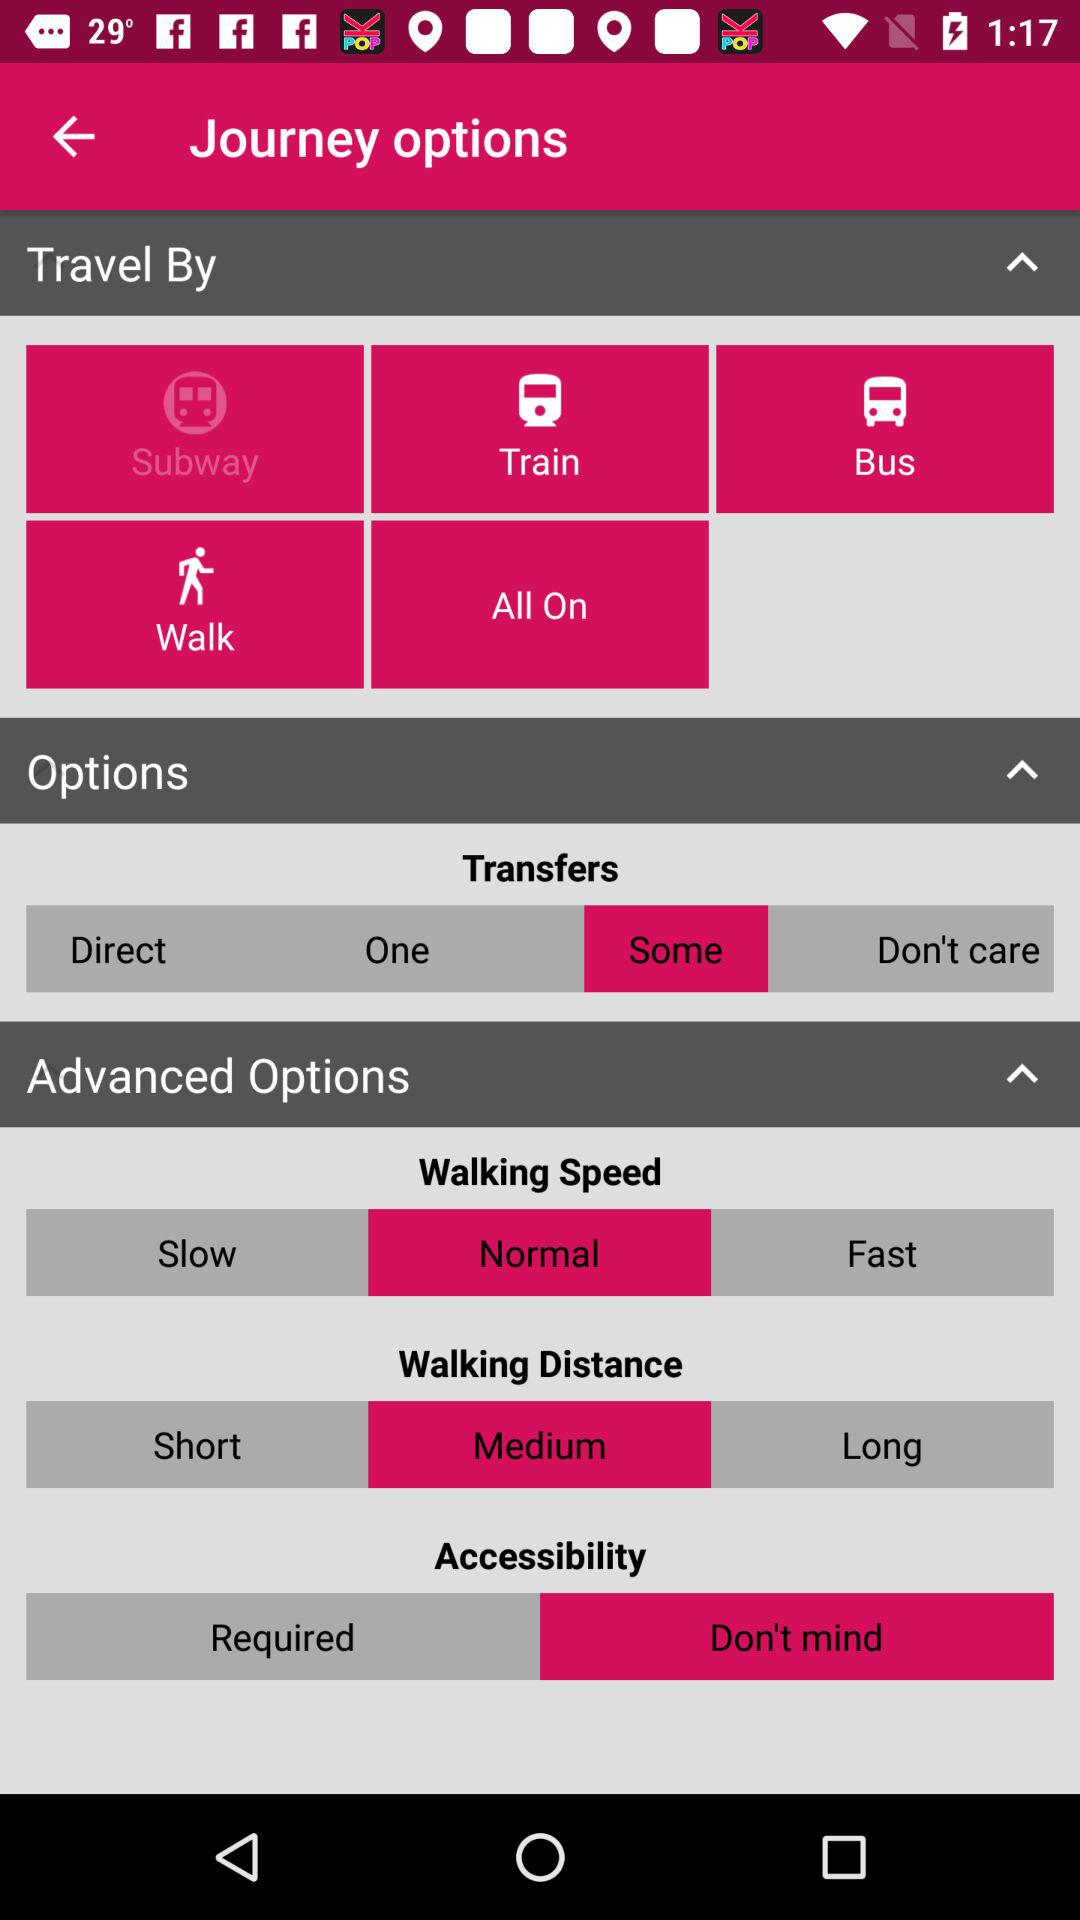What is the status of the walking distance? The status of the walking distance is medium. 